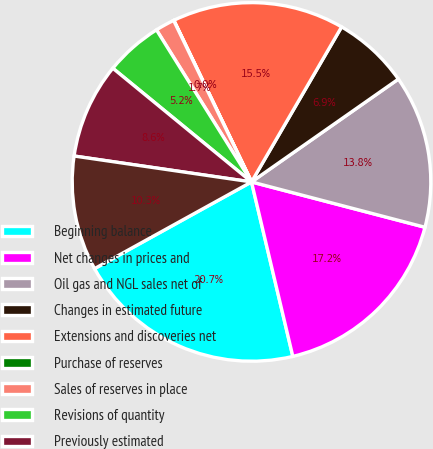Convert chart to OTSL. <chart><loc_0><loc_0><loc_500><loc_500><pie_chart><fcel>Beginning balance<fcel>Net changes in prices and<fcel>Oil gas and NGL sales net of<fcel>Changes in estimated future<fcel>Extensions and discoveries net<fcel>Purchase of reserves<fcel>Sales of reserves in place<fcel>Revisions of quantity<fcel>Previously estimated<fcel>Accretion of discount<nl><fcel>20.67%<fcel>17.23%<fcel>13.79%<fcel>6.9%<fcel>15.51%<fcel>0.02%<fcel>1.74%<fcel>5.18%<fcel>8.62%<fcel>10.34%<nl></chart> 